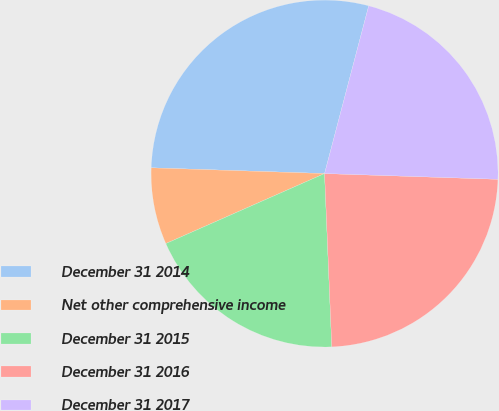<chart> <loc_0><loc_0><loc_500><loc_500><pie_chart><fcel>December 31 2014<fcel>Net other comprehensive income<fcel>December 31 2015<fcel>December 31 2016<fcel>December 31 2017<nl><fcel>28.57%<fcel>7.14%<fcel>19.05%<fcel>23.81%<fcel>21.43%<nl></chart> 